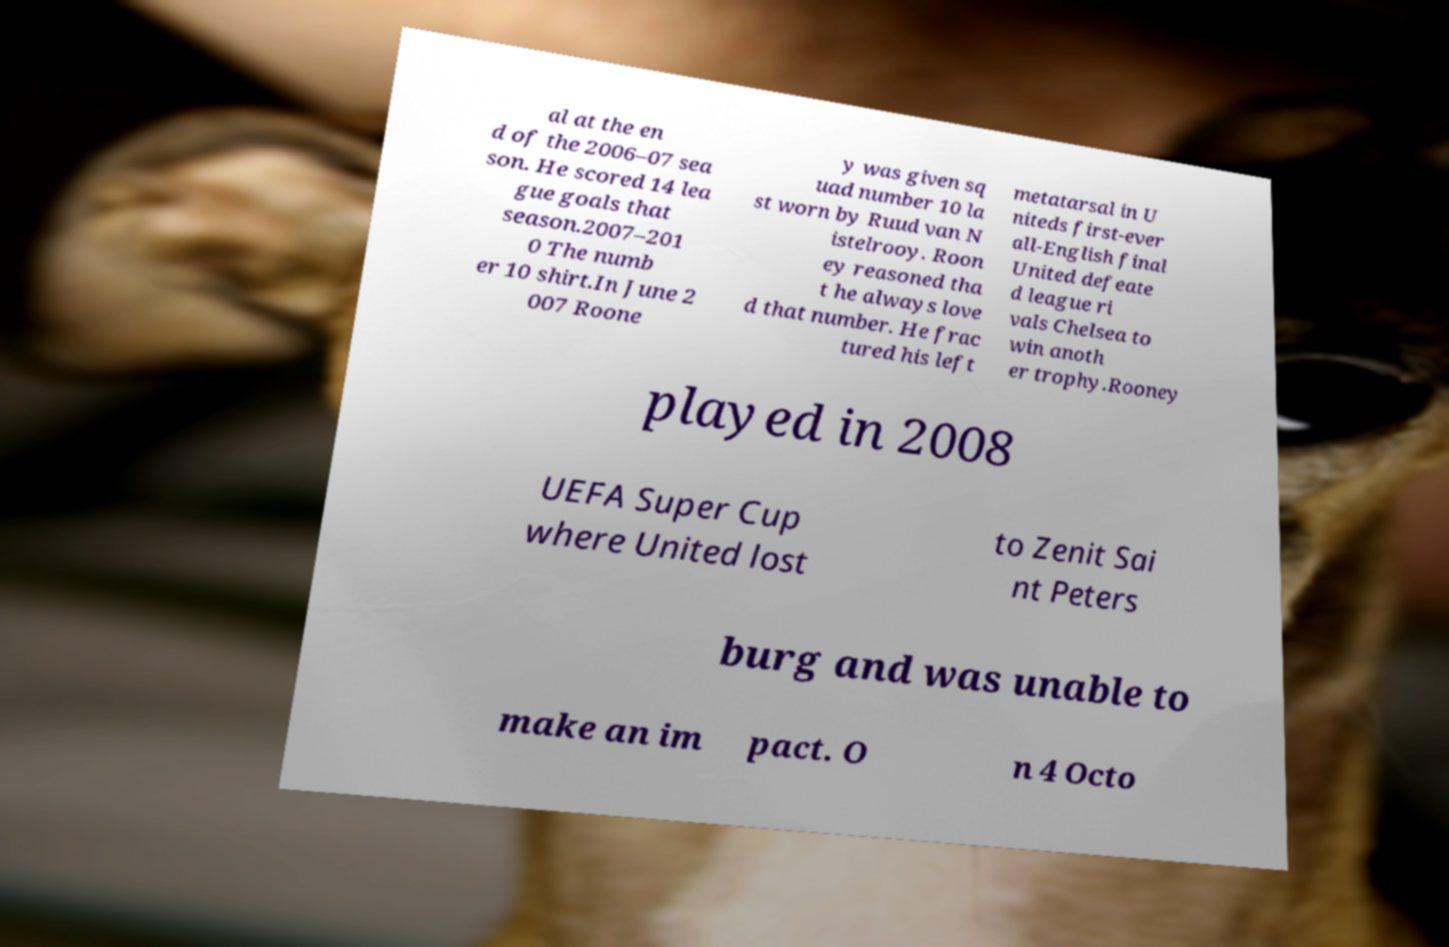There's text embedded in this image that I need extracted. Can you transcribe it verbatim? al at the en d of the 2006–07 sea son. He scored 14 lea gue goals that season.2007–201 0 The numb er 10 shirt.In June 2 007 Roone y was given sq uad number 10 la st worn by Ruud van N istelrooy. Roon ey reasoned tha t he always love d that number. He frac tured his left metatarsal in U niteds first-ever all-English final United defeate d league ri vals Chelsea to win anoth er trophy.Rooney played in 2008 UEFA Super Cup where United lost to Zenit Sai nt Peters burg and was unable to make an im pact. O n 4 Octo 